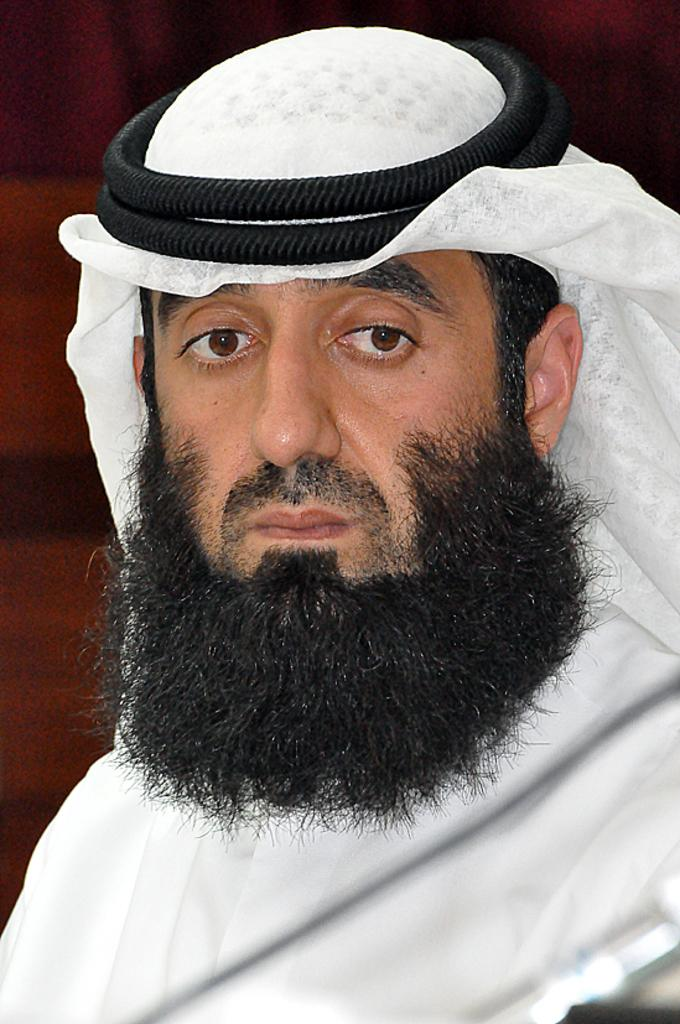What is the main subject of the image? There is a person in the image. What is the person wearing? The person is wearing a white dress and a shemagh on their head. What color is the shemagh? The shemagh is red. What color is the background of the image? The background of the image is red. What type of advertisement can be seen on the person's dress in the image? There is no advertisement visible on the person's dress in the image. What type of polish is being applied to the person's nails in the image? There are no visible nails or polish in the image. 